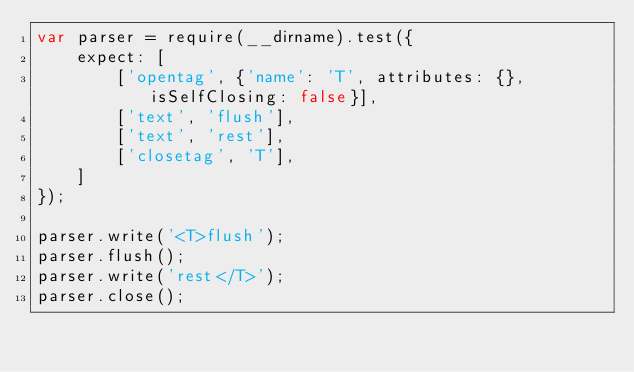<code> <loc_0><loc_0><loc_500><loc_500><_JavaScript_>var parser = require(__dirname).test({
    expect: [
        ['opentag', {'name': 'T', attributes: {}, isSelfClosing: false}],
        ['text', 'flush'],
        ['text', 'rest'],
        ['closetag', 'T'],
    ]
});

parser.write('<T>flush');
parser.flush();
parser.write('rest</T>');
parser.close();
</code> 